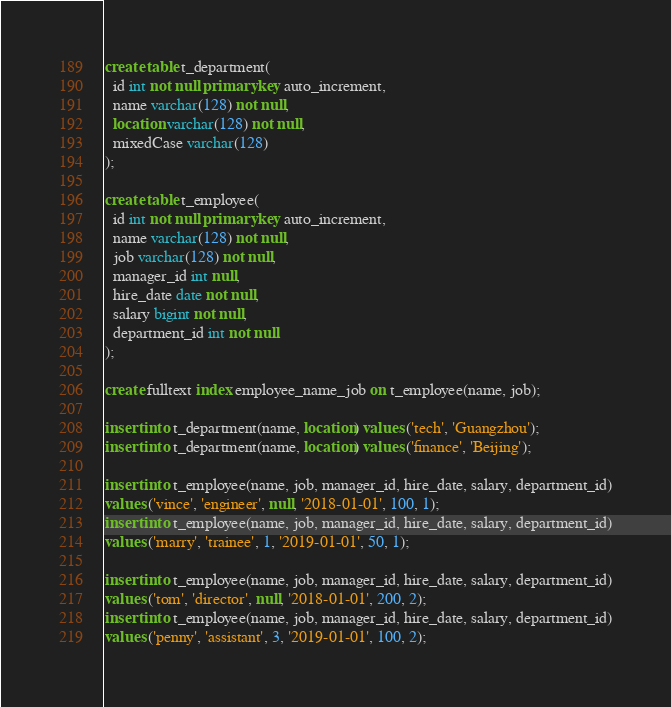<code> <loc_0><loc_0><loc_500><loc_500><_SQL_>
create table t_department(
  id int not null primary key auto_increment,
  name varchar(128) not null,
  location varchar(128) not null,
  mixedCase varchar(128)
);

create table t_employee(
  id int not null primary key auto_increment,
  name varchar(128) not null,
  job varchar(128) not null,
  manager_id int null,
  hire_date date not null,
  salary bigint not null,
  department_id int not null
);

create fulltext index employee_name_job on t_employee(name, job);

insert into t_department(name, location) values ('tech', 'Guangzhou');
insert into t_department(name, location) values ('finance', 'Beijing');

insert into t_employee(name, job, manager_id, hire_date, salary, department_id)
values ('vince', 'engineer', null, '2018-01-01', 100, 1);
insert into t_employee(name, job, manager_id, hire_date, salary, department_id)
values ('marry', 'trainee', 1, '2019-01-01', 50, 1);

insert into t_employee(name, job, manager_id, hire_date, salary, department_id)
values ('tom', 'director', null, '2018-01-01', 200, 2);
insert into t_employee(name, job, manager_id, hire_date, salary, department_id)
values ('penny', 'assistant', 3, '2019-01-01', 100, 2);


</code> 